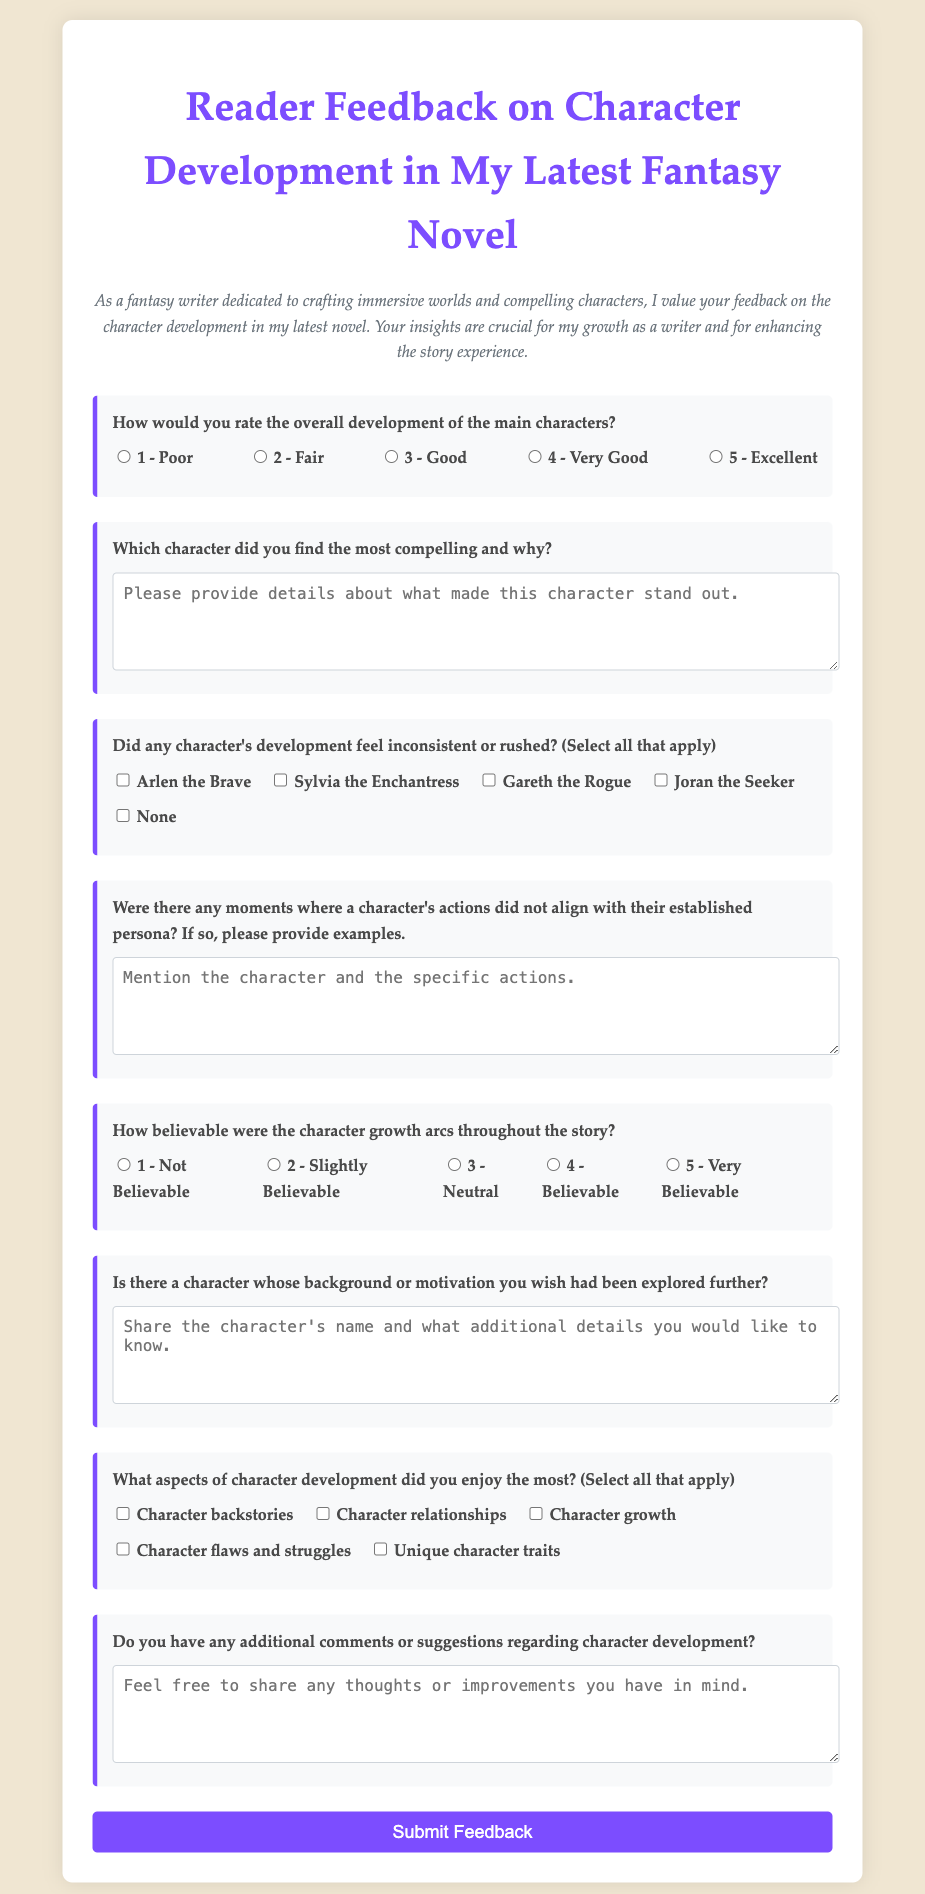What is the title of the survey form? The title of the survey form appears at the top of the document, stating its purpose.
Answer: Reader Feedback on Character Development in My Latest Fantasy Novel How many main characters can be selected as feeling inconsistent or rushed? The document lists multiple characters that respondents can select from when answering the question.
Answer: Five Which character is asked about alongside the option 'None'? The survey includes a character, Arlen the Brave, in the question about character development inconsistencies, presenting multiple options.
Answer: Arlen the Brave What is the highest rating available for overall character development? The rating scale provided allows respondents to evaluate the overall character development, with points ranging from 1 to 5.
Answer: 5 What type of feedback is sought regarding character growth arcs? The survey specifically asks for respondents to rate the believability of character growth arcs, which indicates they are evaluating the development's authenticity.
Answer: Believability Which aspect of character development has a specific checkbox for 'Character backstories'? The survey asks respondents which aspects they enjoyed the most, providing checkboxes for multiple options.
Answer: Aspects of character development What is the color of the button used to submit feedback? The design details specify that the button has a particular background color, enhancing its appearance and visibility.
Answer: Purple In what section of the form is the character whose background or motivation is wished to be explored further discussed? The form has a question specifically asking for feedback on characters whose background or motivations may require more exploration, found in a designated section.
Answer: Section for character background or motivation 